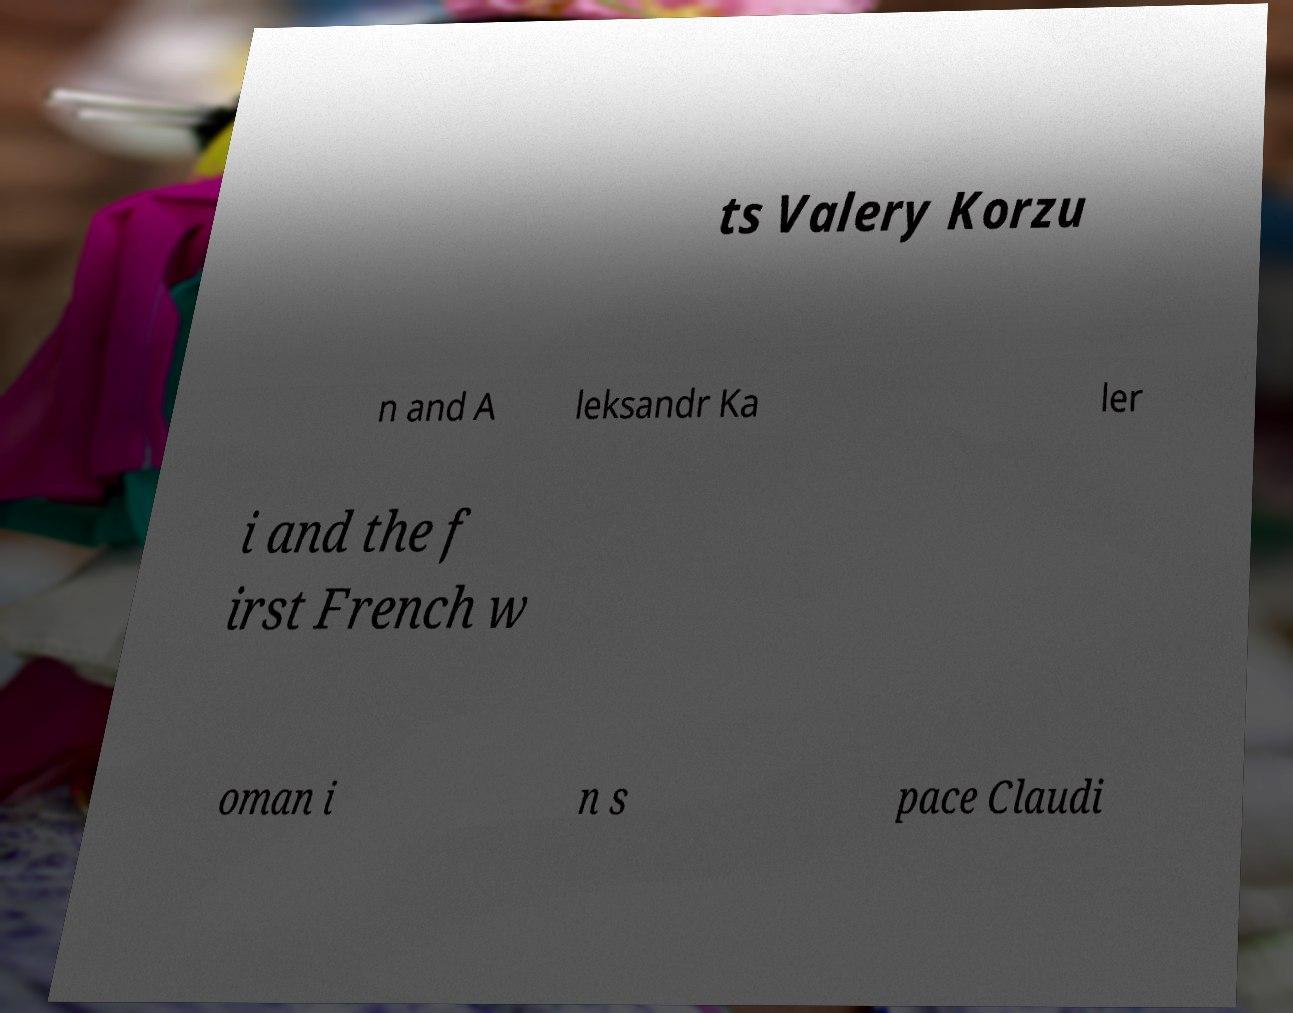Can you accurately transcribe the text from the provided image for me? ts Valery Korzu n and A leksandr Ka ler i and the f irst French w oman i n s pace Claudi 